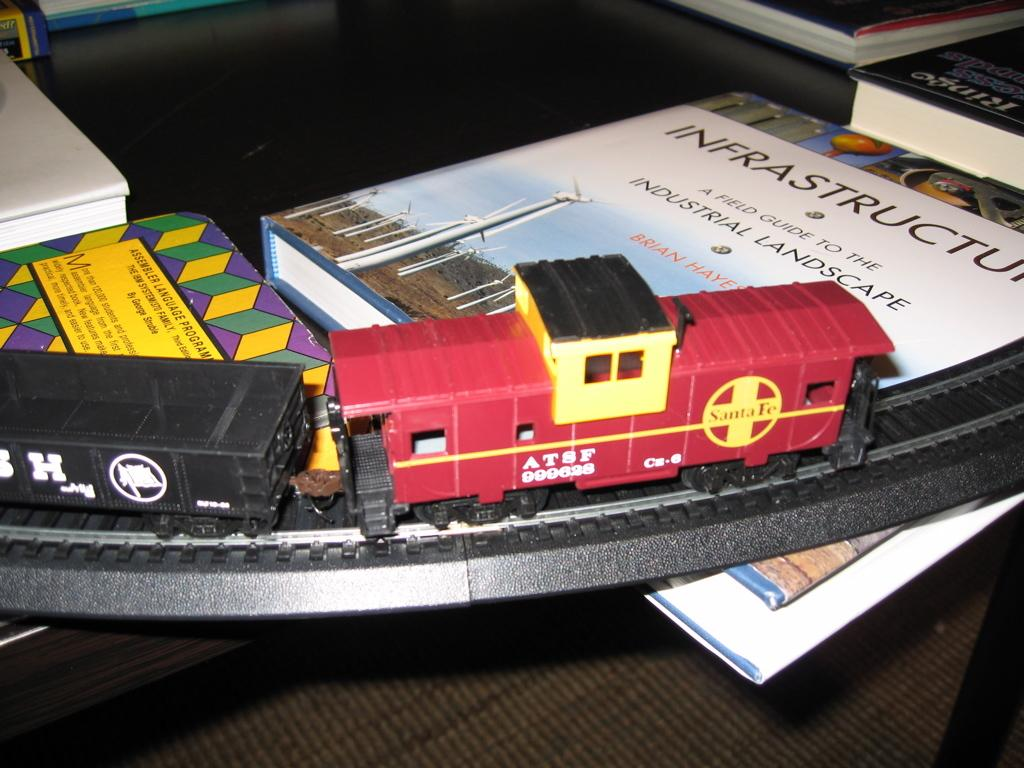<image>
Present a compact description of the photo's key features. A toy train going over a book called Infrastructure. 